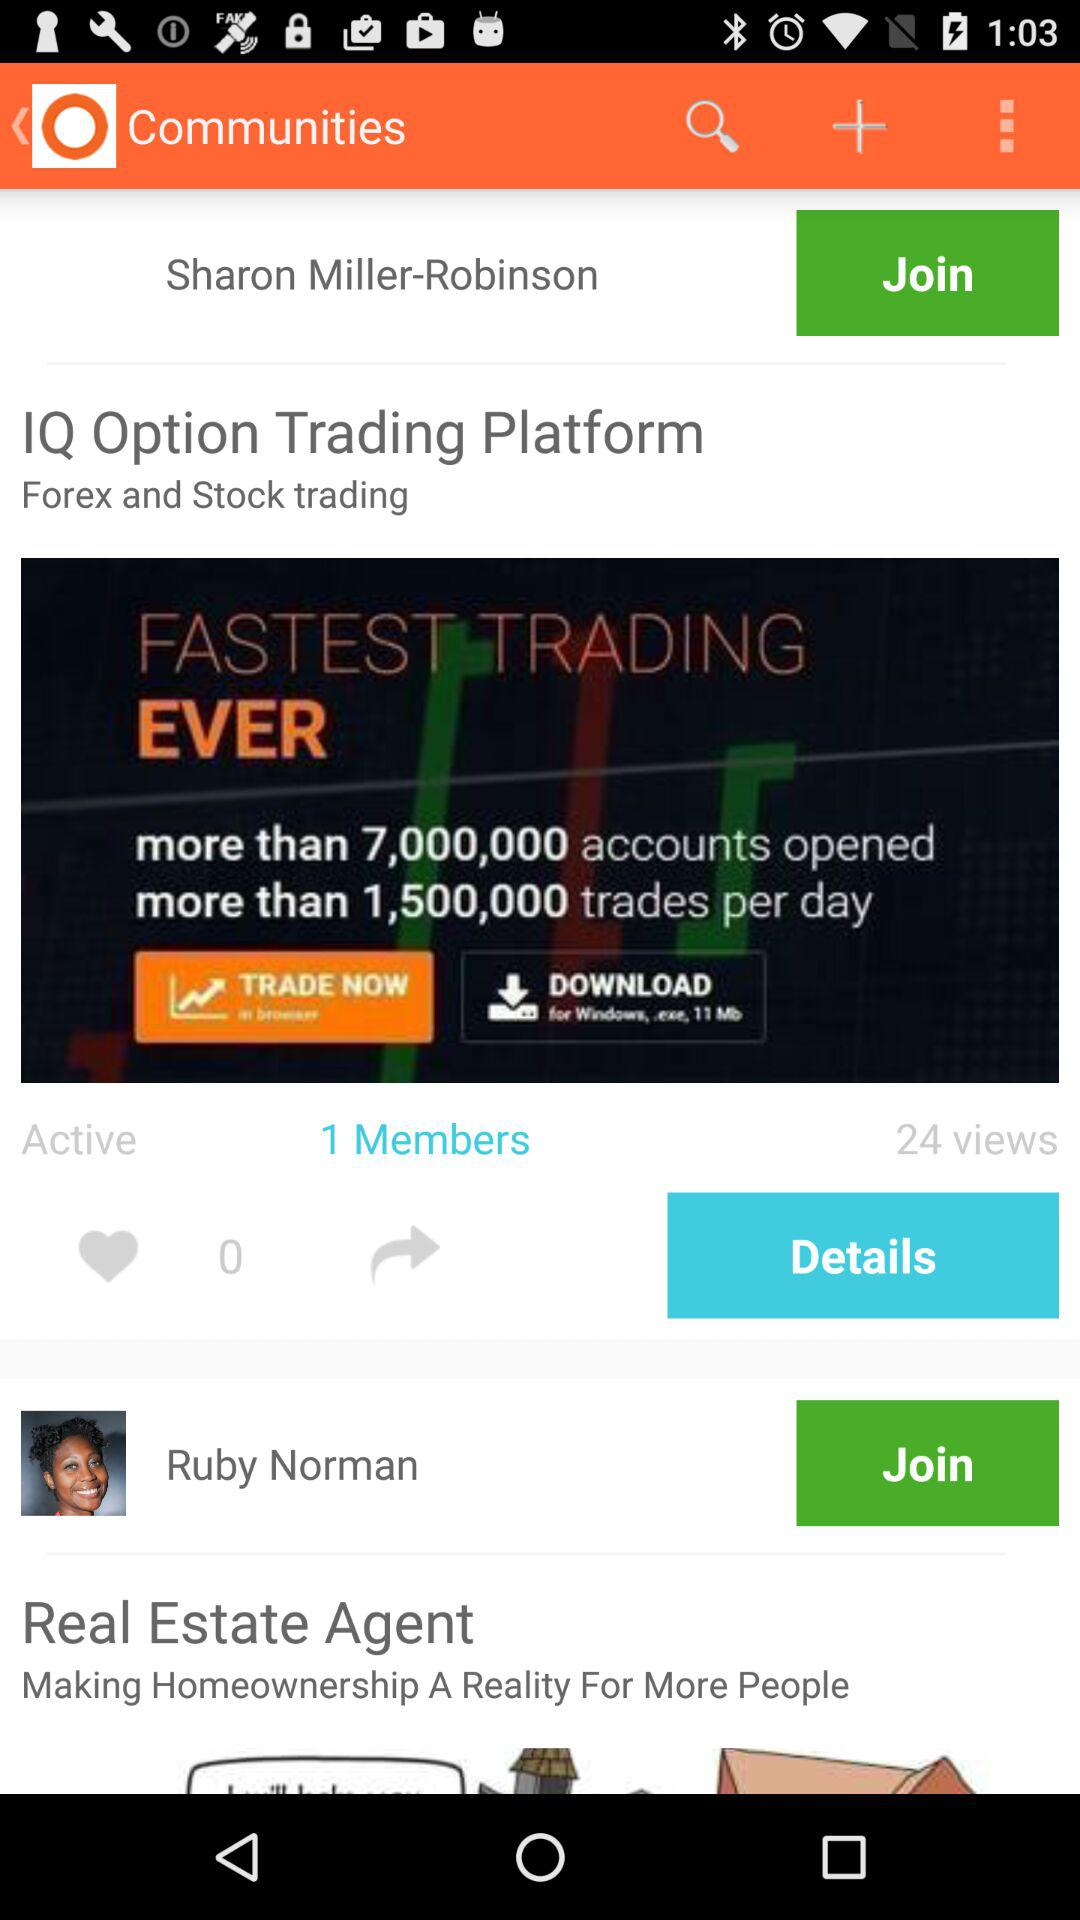What is the status of user?
When the provided information is insufficient, respond with <no answer>. <no answer> 